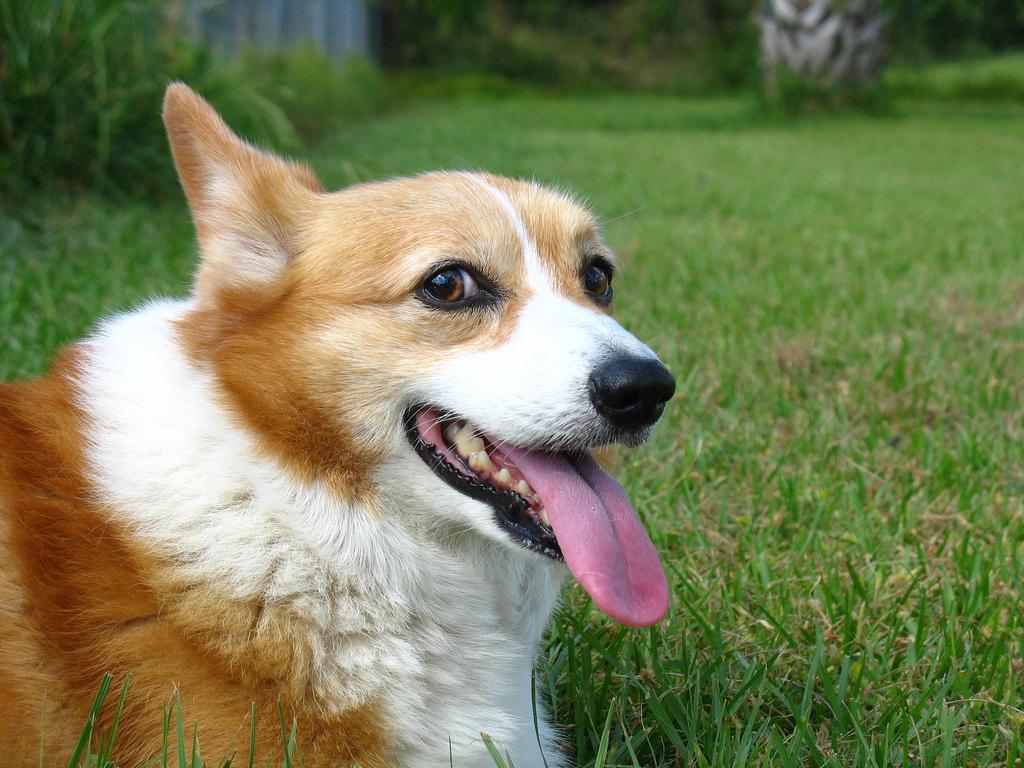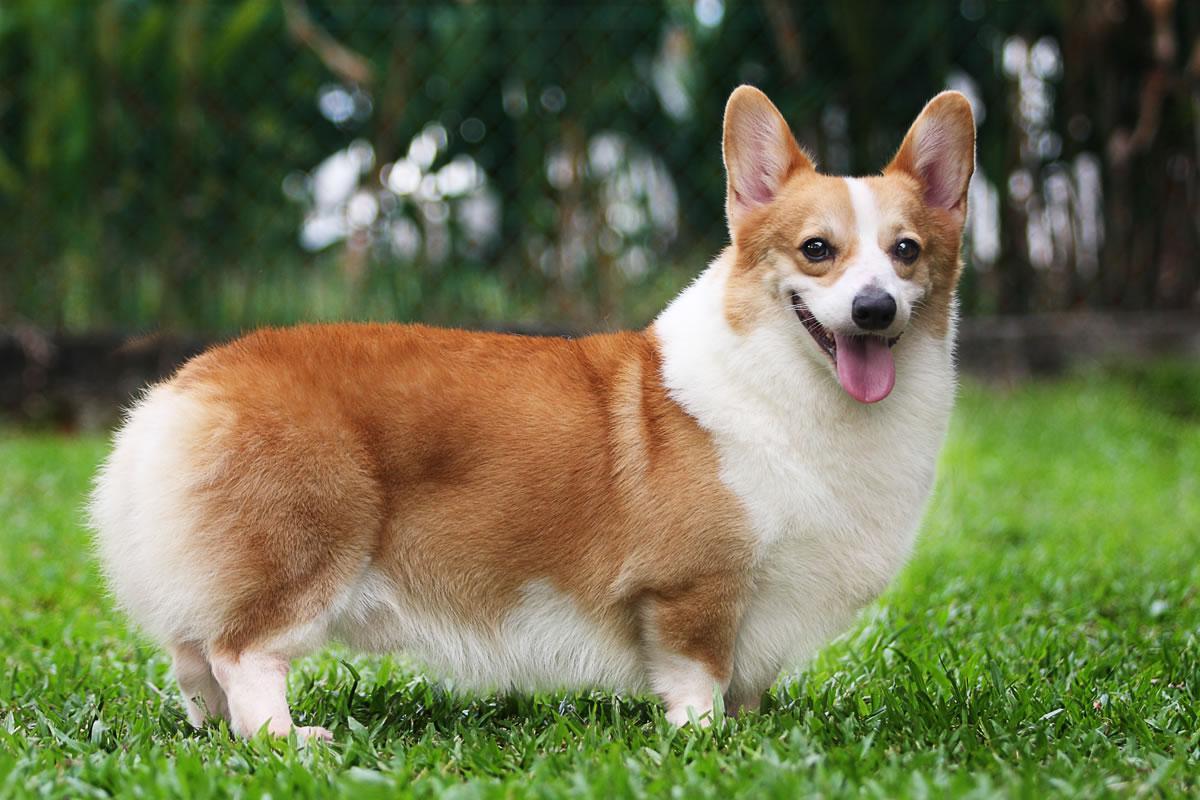The first image is the image on the left, the second image is the image on the right. Considering the images on both sides, is "One image shows a grinning, close-mouthed corgi with ears that splay outward, sitting upright in grass." valid? Answer yes or no. No. 